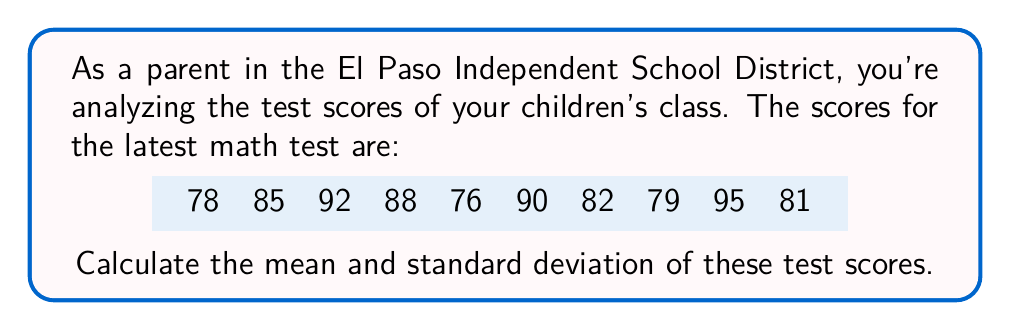Give your solution to this math problem. Let's approach this step-by-step:

1. Calculate the mean:
   The mean is the sum of all values divided by the number of values.
   
   $$ \text{Mean} = \frac{\sum_{i=1}^{n} x_i}{n} $$
   
   Sum of scores: 78 + 85 + 92 + 88 + 76 + 90 + 82 + 79 + 95 + 81 = 846
   Number of scores: 10
   
   $$ \text{Mean} = \frac{846}{10} = 84.6 $$

2. Calculate the standard deviation:
   The standard deviation is the square root of the variance, which is the average of the squared differences from the mean.
   
   $$ \text{Standard Deviation} = \sqrt{\frac{\sum_{i=1}^{n} (x_i - \bar{x})^2}{n-1}} $$
   
   Where $\bar{x}$ is the mean and $n$ is the number of values.

   First, calculate $(x_i - \bar{x})^2$ for each score:
   $$(78 - 84.6)^2 = 43.56$$
   $$(85 - 84.6)^2 = 0.16$$
   $$(92 - 84.6)^2 = 54.76$$
   $$(88 - 84.6)^2 = 11.56$$
   $$(76 - 84.6)^2 = 73.96$$
   $$(90 - 84.6)^2 = 29.16$$
   $$(82 - 84.6)^2 = 6.76$$
   $$(79 - 84.6)^2 = 31.36$$
   $$(95 - 84.6)^2 = 108.16$$
   $$(81 - 84.6)^2 = 12.96$$

   Sum these values: 372.4

   Now apply the formula:
   $$ \text{Standard Deviation} = \sqrt{\frac{372.4}{9}} = \sqrt{41.3778} \approx 6.43 $$
Answer: Mean: 84.6, Standard Deviation: 6.43 